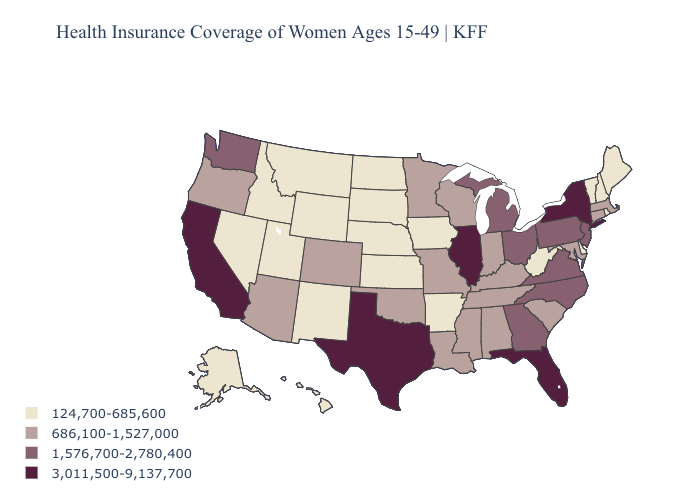What is the value of Kansas?
Quick response, please. 124,700-685,600. Name the states that have a value in the range 3,011,500-9,137,700?
Give a very brief answer. California, Florida, Illinois, New York, Texas. Does Rhode Island have a lower value than Arkansas?
Keep it brief. No. What is the highest value in the USA?
Give a very brief answer. 3,011,500-9,137,700. What is the highest value in states that border New Mexico?
Short answer required. 3,011,500-9,137,700. Does New Jersey have the lowest value in the USA?
Concise answer only. No. What is the value of North Carolina?
Keep it brief. 1,576,700-2,780,400. Does North Dakota have the same value as Rhode Island?
Keep it brief. Yes. Does New Mexico have the highest value in the West?
Write a very short answer. No. What is the value of South Dakota?
Concise answer only. 124,700-685,600. What is the highest value in states that border Utah?
Concise answer only. 686,100-1,527,000. Does Rhode Island have the highest value in the Northeast?
Keep it brief. No. Does New Hampshire have the lowest value in the Northeast?
Give a very brief answer. Yes. Among the states that border Colorado , which have the highest value?
Give a very brief answer. Arizona, Oklahoma. What is the value of Alaska?
Short answer required. 124,700-685,600. 